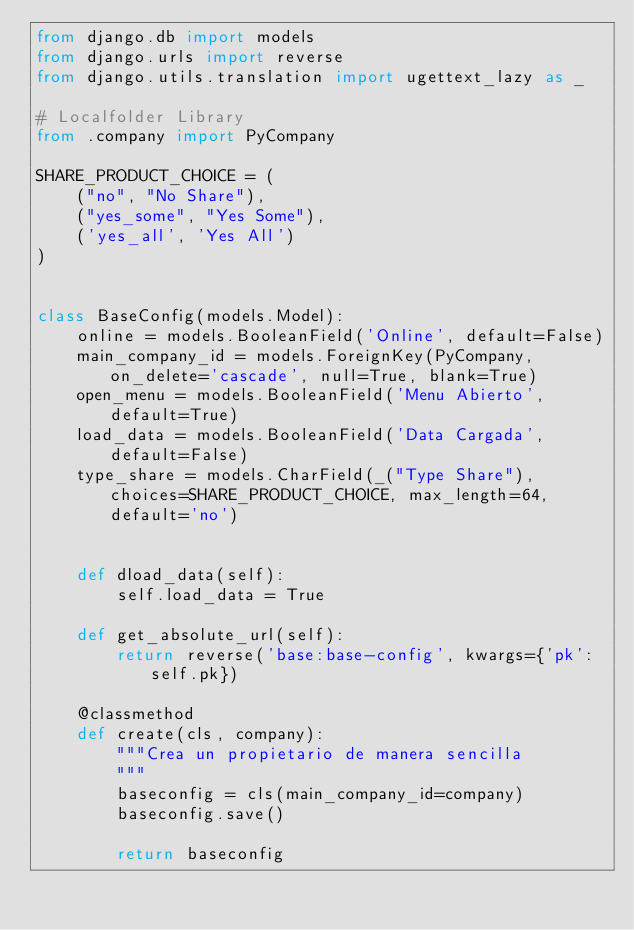<code> <loc_0><loc_0><loc_500><loc_500><_Python_>from django.db import models
from django.urls import reverse
from django.utils.translation import ugettext_lazy as _

# Localfolder Library
from .company import PyCompany

SHARE_PRODUCT_CHOICE = (
    ("no", "No Share"),
    ("yes_some", "Yes Some"),
    ('yes_all', 'Yes All')
)


class BaseConfig(models.Model):
    online = models.BooleanField('Online', default=False)
    main_company_id = models.ForeignKey(PyCompany, on_delete='cascade', null=True, blank=True)
    open_menu = models.BooleanField('Menu Abierto', default=True)
    load_data = models.BooleanField('Data Cargada', default=False)
    type_share = models.CharField(_("Type Share"), choices=SHARE_PRODUCT_CHOICE, max_length=64, default='no')


    def dload_data(self):
        self.load_data = True

    def get_absolute_url(self):
        return reverse('base:base-config', kwargs={'pk': self.pk})

    @classmethod
    def create(cls, company):
        """Crea un propietario de manera sencilla
        """
        baseconfig = cls(main_company_id=company)
        baseconfig.save()

        return baseconfig
</code> 